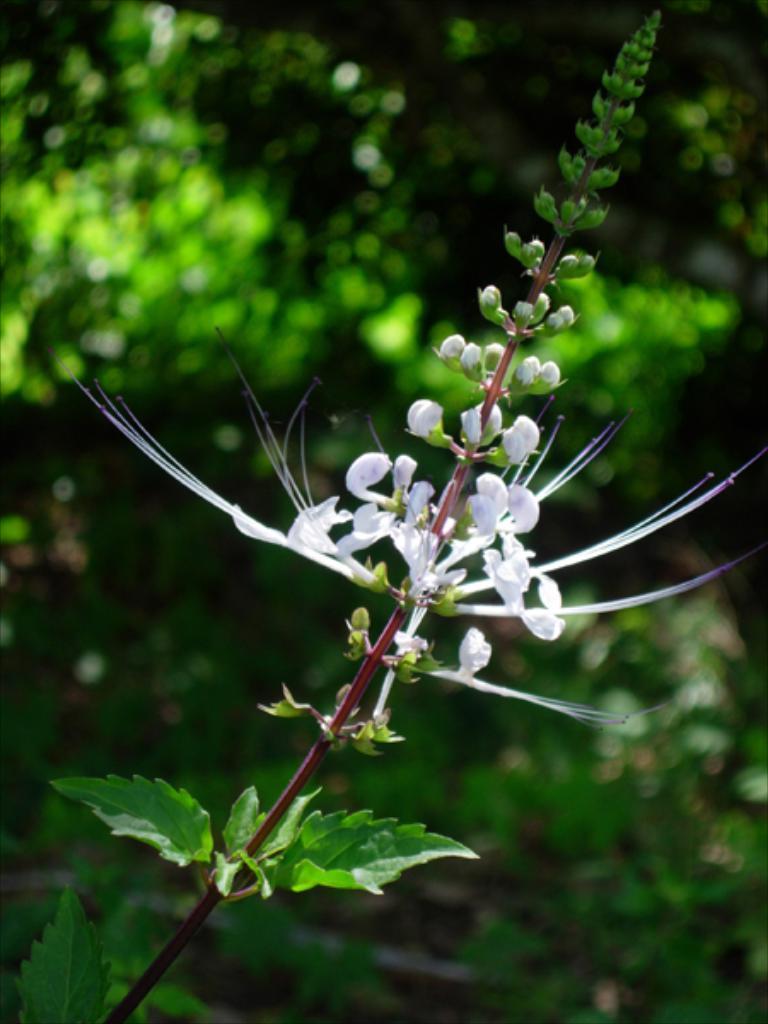Can you describe this image briefly? In this image there is a plant having flowers, buds and leaves. Background is blurry. 